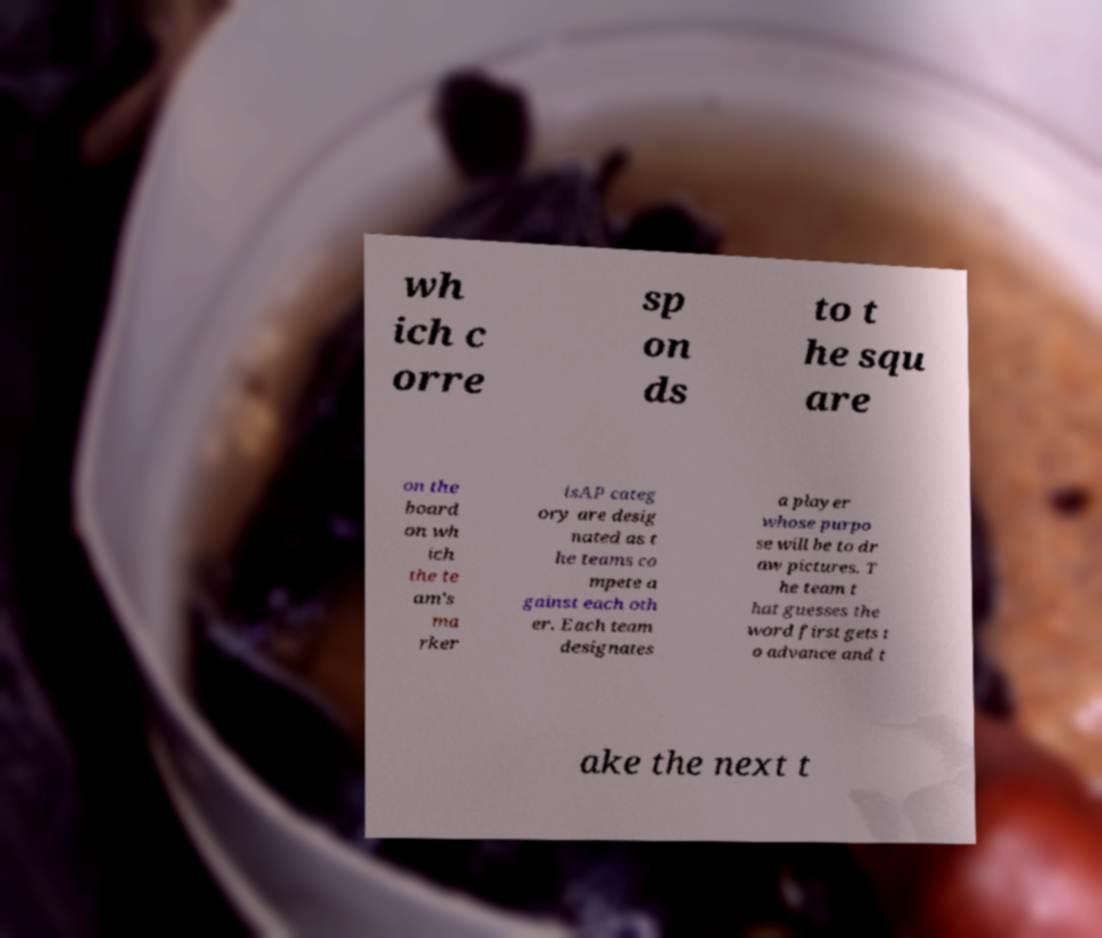What messages or text are displayed in this image? I need them in a readable, typed format. wh ich c orre sp on ds to t he squ are on the board on wh ich the te am's ma rker isAP categ ory are desig nated as t he teams co mpete a gainst each oth er. Each team designates a player whose purpo se will be to dr aw pictures. T he team t hat guesses the word first gets t o advance and t ake the next t 